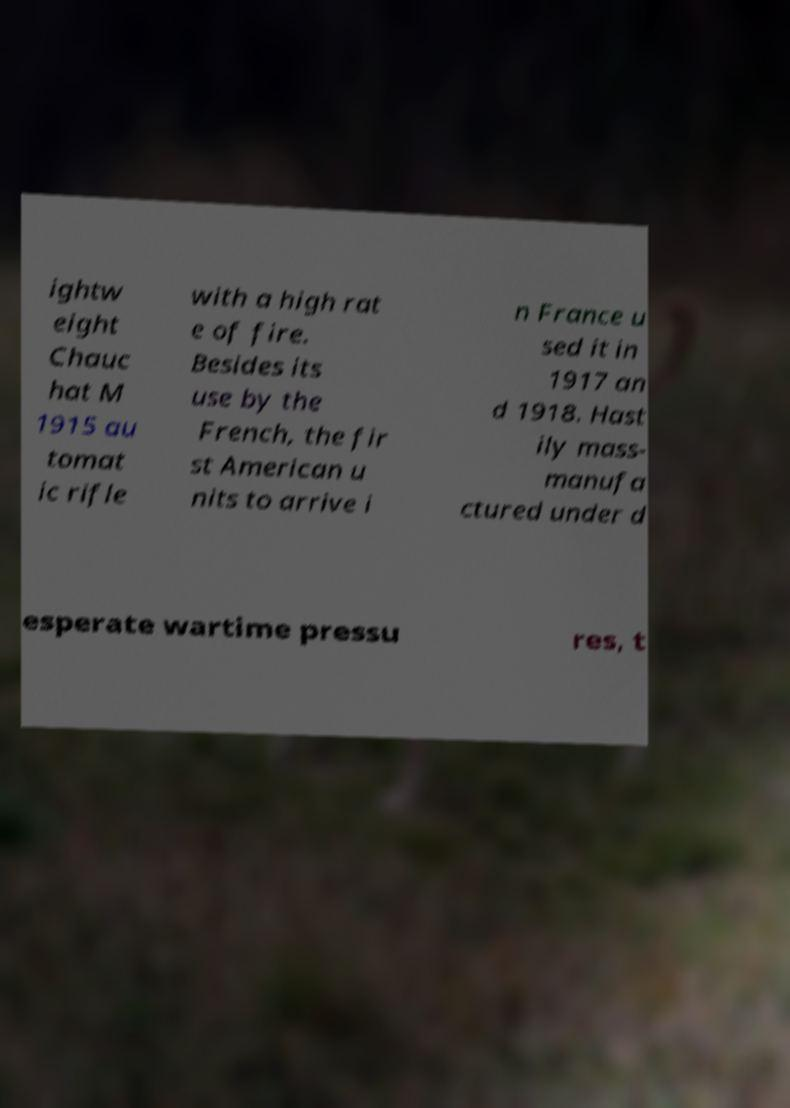Please read and relay the text visible in this image. What does it say? ightw eight Chauc hat M 1915 au tomat ic rifle with a high rat e of fire. Besides its use by the French, the fir st American u nits to arrive i n France u sed it in 1917 an d 1918. Hast ily mass- manufa ctured under d esperate wartime pressu res, t 